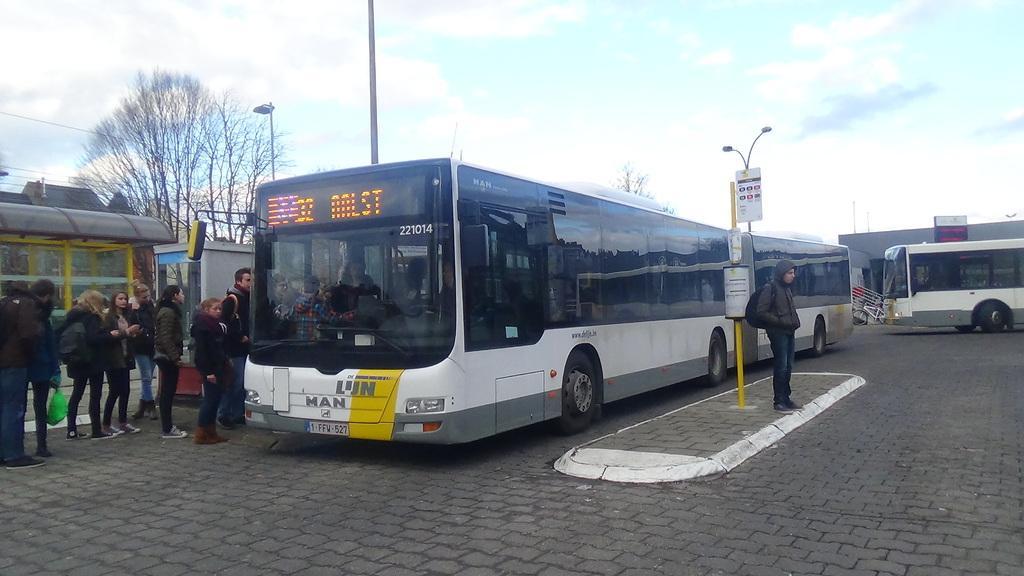In one or two sentences, can you explain what this image depicts? This picture is clicked outside the city. Here, we see buses moving on the road. Beside the bus, we see a pole and street light. Beside that, the man in black jacket who is wearing black backpack is standing. On the left side, we see people standing on the road. Behind them, we see a building. In the background, there are trees and street lights. At the top of the picture, we see the sky. 